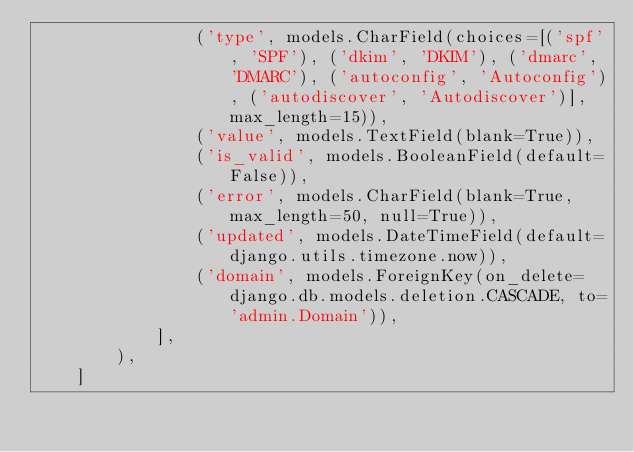Convert code to text. <code><loc_0><loc_0><loc_500><loc_500><_Python_>                ('type', models.CharField(choices=[('spf', 'SPF'), ('dkim', 'DKIM'), ('dmarc', 'DMARC'), ('autoconfig', 'Autoconfig'), ('autodiscover', 'Autodiscover')], max_length=15)),
                ('value', models.TextField(blank=True)),
                ('is_valid', models.BooleanField(default=False)),
                ('error', models.CharField(blank=True, max_length=50, null=True)),
                ('updated', models.DateTimeField(default=django.utils.timezone.now)),
                ('domain', models.ForeignKey(on_delete=django.db.models.deletion.CASCADE, to='admin.Domain')),
            ],
        ),
    ]
</code> 